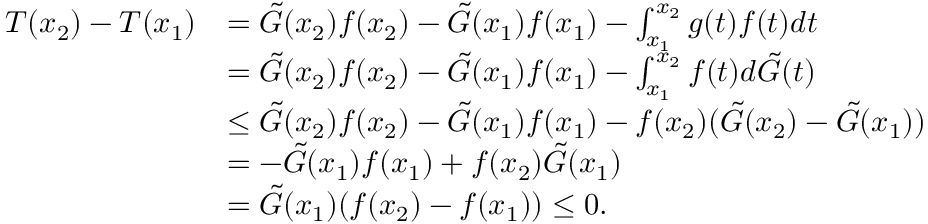Convert formula to latex. <formula><loc_0><loc_0><loc_500><loc_500>\begin{array} { r l } { T ( x _ { 2 } ) - T ( x _ { 1 } ) } & { = \tilde { G } ( x _ { 2 } ) f ( x _ { 2 } ) - \tilde { G } ( x _ { 1 } ) f ( x _ { 1 } ) - \int _ { x _ { 1 } } ^ { x _ { 2 } } g ( t ) f ( t ) d t } \\ & { = \tilde { G } ( x _ { 2 } ) f ( x _ { 2 } ) - \tilde { G } ( x _ { 1 } ) f ( x _ { 1 } ) - \int _ { x _ { 1 } } ^ { x _ { 2 } } f ( t ) d \tilde { G } ( t ) } \\ & { \leq \tilde { G } ( x _ { 2 } ) f ( x _ { 2 } ) - \tilde { G } ( x _ { 1 } ) f ( x _ { 1 } ) - f ( x _ { 2 } ) ( \tilde { G } ( x _ { 2 } ) - \tilde { G } ( x _ { 1 } ) ) } \\ & { = - \tilde { G } ( x _ { 1 } ) f ( x _ { 1 } ) + f ( x _ { 2 } ) \tilde { G } ( x _ { 1 } ) } \\ & { = \tilde { G } ( x _ { 1 } ) ( f ( x _ { 2 } ) - f ( x _ { 1 } ) ) \leq 0 . } \end{array}</formula> 